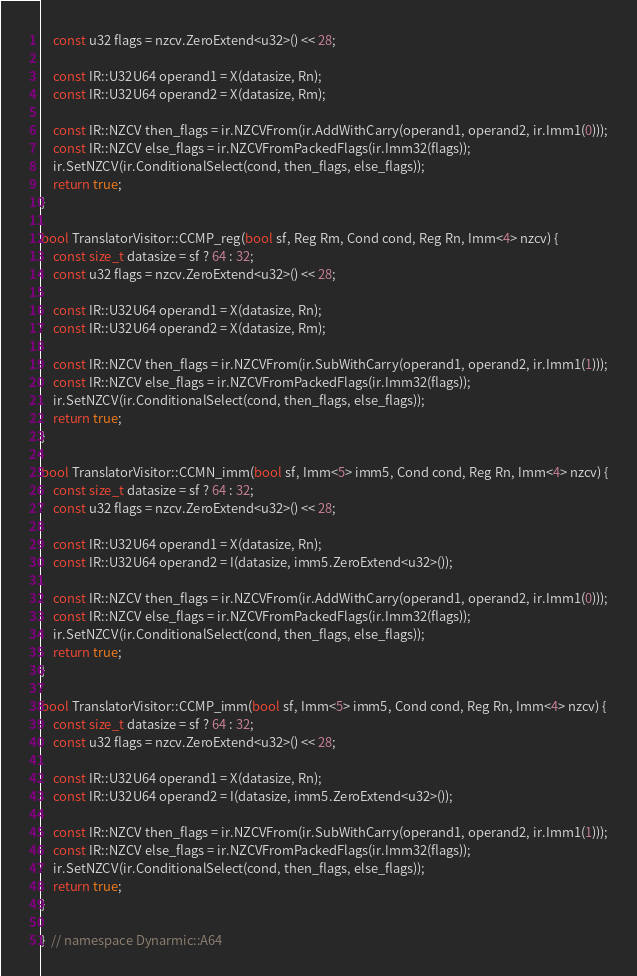<code> <loc_0><loc_0><loc_500><loc_500><_C++_>    const u32 flags = nzcv.ZeroExtend<u32>() << 28;

    const IR::U32U64 operand1 = X(datasize, Rn);
    const IR::U32U64 operand2 = X(datasize, Rm);

    const IR::NZCV then_flags = ir.NZCVFrom(ir.AddWithCarry(operand1, operand2, ir.Imm1(0)));
    const IR::NZCV else_flags = ir.NZCVFromPackedFlags(ir.Imm32(flags));
    ir.SetNZCV(ir.ConditionalSelect(cond, then_flags, else_flags));
    return true;
}

bool TranslatorVisitor::CCMP_reg(bool sf, Reg Rm, Cond cond, Reg Rn, Imm<4> nzcv) {
    const size_t datasize = sf ? 64 : 32;
    const u32 flags = nzcv.ZeroExtend<u32>() << 28;

    const IR::U32U64 operand1 = X(datasize, Rn);
    const IR::U32U64 operand2 = X(datasize, Rm);

    const IR::NZCV then_flags = ir.NZCVFrom(ir.SubWithCarry(operand1, operand2, ir.Imm1(1)));
    const IR::NZCV else_flags = ir.NZCVFromPackedFlags(ir.Imm32(flags));
    ir.SetNZCV(ir.ConditionalSelect(cond, then_flags, else_flags));
    return true;
}

bool TranslatorVisitor::CCMN_imm(bool sf, Imm<5> imm5, Cond cond, Reg Rn, Imm<4> nzcv) {
    const size_t datasize = sf ? 64 : 32;
    const u32 flags = nzcv.ZeroExtend<u32>() << 28;

    const IR::U32U64 operand1 = X(datasize, Rn);
    const IR::U32U64 operand2 = I(datasize, imm5.ZeroExtend<u32>());

    const IR::NZCV then_flags = ir.NZCVFrom(ir.AddWithCarry(operand1, operand2, ir.Imm1(0)));
    const IR::NZCV else_flags = ir.NZCVFromPackedFlags(ir.Imm32(flags));
    ir.SetNZCV(ir.ConditionalSelect(cond, then_flags, else_flags));
    return true;
}

bool TranslatorVisitor::CCMP_imm(bool sf, Imm<5> imm5, Cond cond, Reg Rn, Imm<4> nzcv) {
    const size_t datasize = sf ? 64 : 32;
    const u32 flags = nzcv.ZeroExtend<u32>() << 28;

    const IR::U32U64 operand1 = X(datasize, Rn);
    const IR::U32U64 operand2 = I(datasize, imm5.ZeroExtend<u32>());

    const IR::NZCV then_flags = ir.NZCVFrom(ir.SubWithCarry(operand1, operand2, ir.Imm1(1)));
    const IR::NZCV else_flags = ir.NZCVFromPackedFlags(ir.Imm32(flags));
    ir.SetNZCV(ir.ConditionalSelect(cond, then_flags, else_flags));
    return true;
}

}  // namespace Dynarmic::A64
</code> 